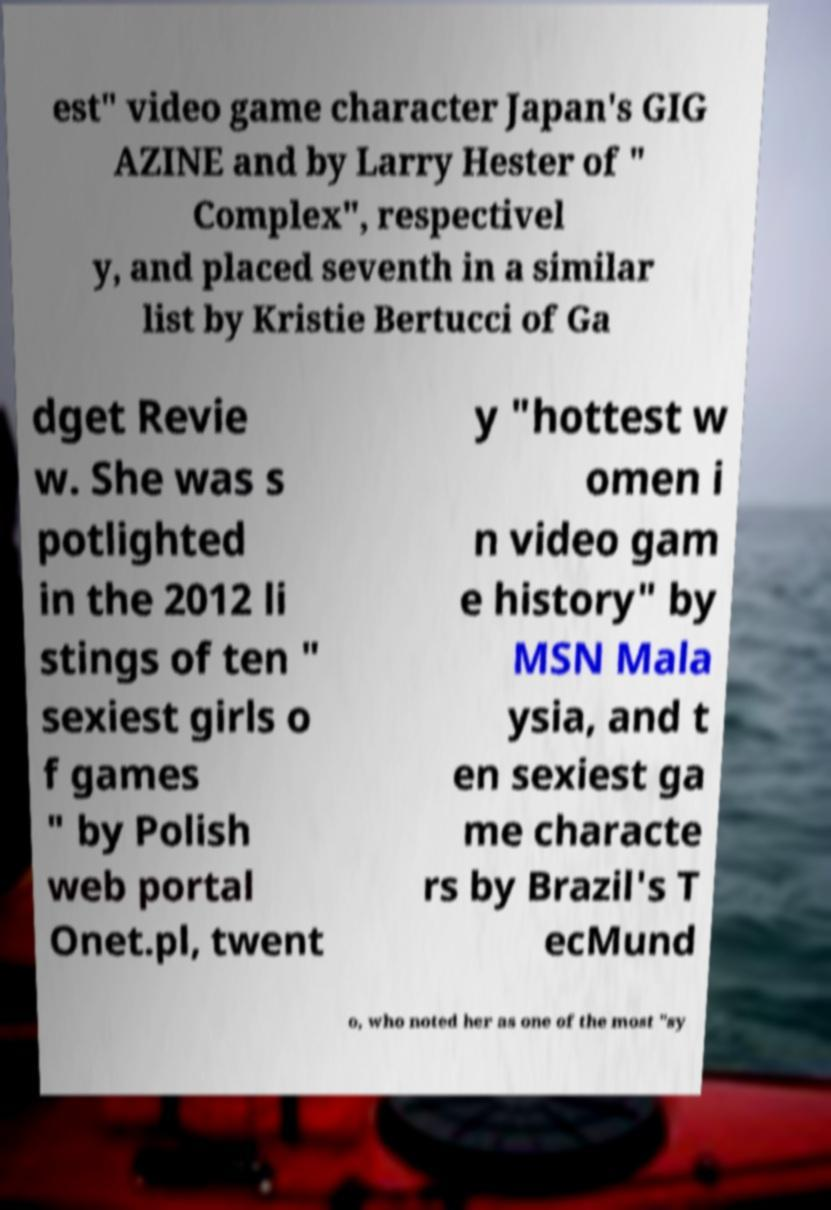Can you read and provide the text displayed in the image?This photo seems to have some interesting text. Can you extract and type it out for me? est" video game character Japan's GIG AZINE and by Larry Hester of " Complex", respectivel y, and placed seventh in a similar list by Kristie Bertucci of Ga dget Revie w. She was s potlighted in the 2012 li stings of ten " sexiest girls o f games " by Polish web portal Onet.pl, twent y "hottest w omen i n video gam e history" by MSN Mala ysia, and t en sexiest ga me characte rs by Brazil's T ecMund o, who noted her as one of the most "sy 